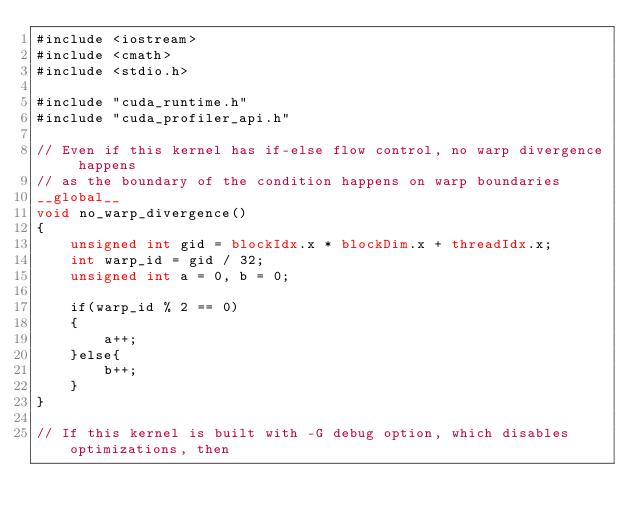Convert code to text. <code><loc_0><loc_0><loc_500><loc_500><_Cuda_>#include <iostream>
#include <cmath>
#include <stdio.h>

#include "cuda_runtime.h"
#include "cuda_profiler_api.h"

// Even if this kernel has if-else flow control, no warp divergence happens
// as the boundary of the condition happens on warp boundaries
__global__
void no_warp_divergence()
{
    unsigned int gid = blockIdx.x * blockDim.x + threadIdx.x;
    int warp_id = gid / 32;
    unsigned int a = 0, b = 0;

    if(warp_id % 2 == 0)
    {
        a++;
    }else{
        b++;
    }
}

// If this kernel is built with -G debug option, which disables optimizations, then</code> 